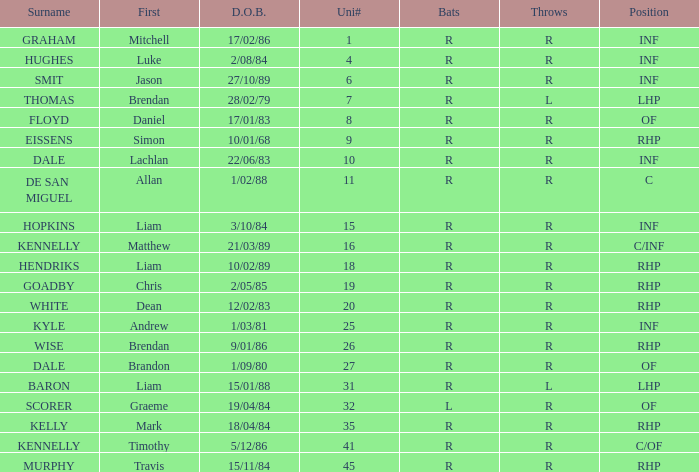Which batter has a uni# of 31? R. 